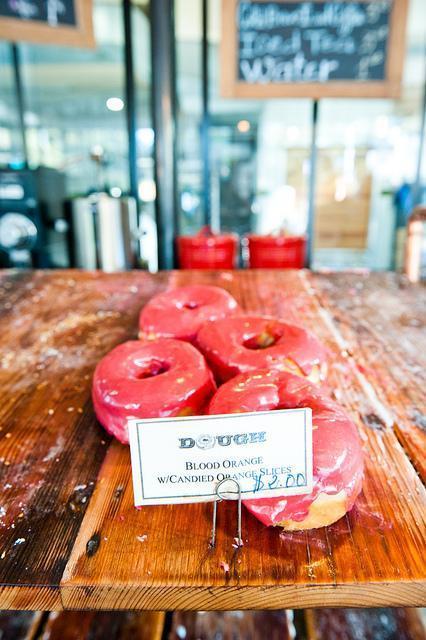How many donuts?
Give a very brief answer. 4. How many donuts are in the picture?
Give a very brief answer. 4. How many train cars have some yellow on them?
Give a very brief answer. 0. 